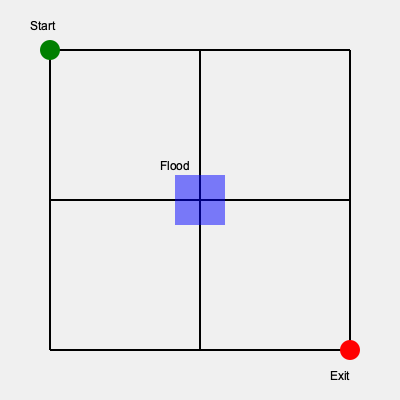Given the street map above, where green represents the starting point, red represents the exit point, and the blue area indicates flooding, which route would be the most efficient for evacuation? To determine the most efficient evacuation route, we need to consider the following steps:

1. Identify the starting point (green) and exit point (red).
2. Locate the flooded area (blue) that needs to be avoided.
3. Analyze potential routes:
   a. Route 1: Right → Down → Right
   b. Route 2: Down → Right → Down
   c. Route 3: Right → Down → Left → Down → Right

4. Calculate the distance for each route:
   Route 1: $2 \times 150 + 150 = 450$ units
   Route 2: $2 \times 150 + 150 = 450$ units
   Route 3: $4 \times 150 + 150 = 750$ units

5. Consider safety factors:
   - Route 1 passes directly below the flooded area, which may be risky.
   - Route 2 passes directly to the left of the flooded area, which may also be risky.
   - Route 3 avoids the flooded area entirely but is significantly longer.

6. Evaluate efficiency:
   - Routes 1 and 2 are equally short but may pose safety risks.
   - Route 3 is safest but considerably longer.

7. Conclusion: The most efficient route balances safety and distance. In this case, Route 2 (Down → Right → Down) is slightly preferable as it maintains some distance from the flooded area while keeping the path short.
Answer: Down → Right → Down 